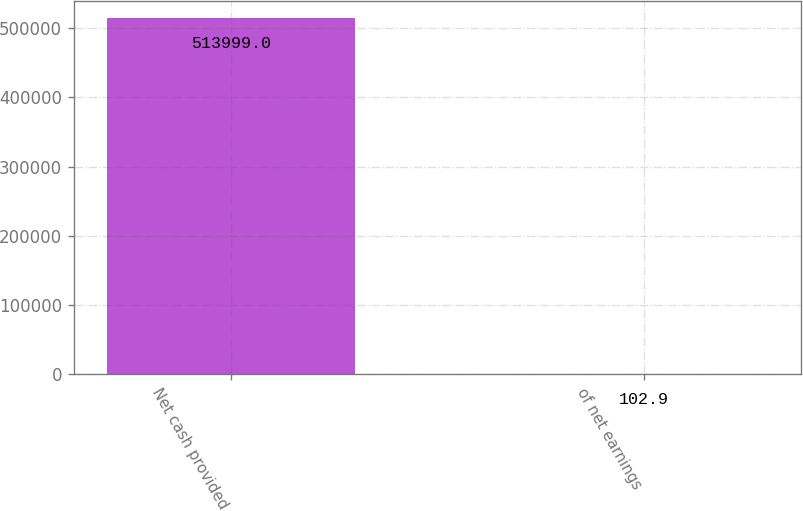Convert chart. <chart><loc_0><loc_0><loc_500><loc_500><bar_chart><fcel>Net cash provided<fcel>of net earnings<nl><fcel>513999<fcel>102.9<nl></chart> 